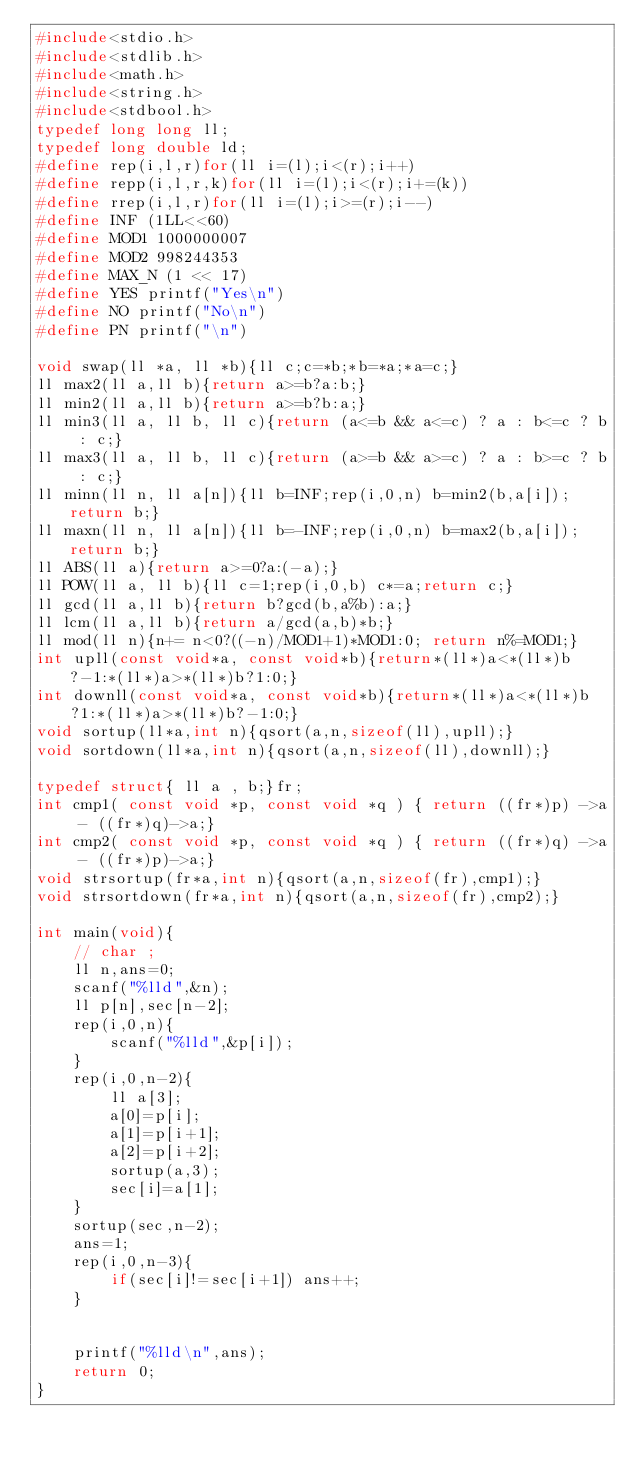Convert code to text. <code><loc_0><loc_0><loc_500><loc_500><_C_>#include<stdio.h>
#include<stdlib.h>
#include<math.h>
#include<string.h>
#include<stdbool.h>
typedef long long ll;
typedef long double ld;
#define rep(i,l,r)for(ll i=(l);i<(r);i++)
#define repp(i,l,r,k)for(ll i=(l);i<(r);i+=(k))
#define rrep(i,l,r)for(ll i=(l);i>=(r);i--)
#define INF (1LL<<60)
#define MOD1 1000000007
#define MOD2 998244353
#define MAX_N (1 << 17)
#define YES printf("Yes\n")
#define NO printf("No\n")
#define PN printf("\n")

void swap(ll *a, ll *b){ll c;c=*b;*b=*a;*a=c;}
ll max2(ll a,ll b){return a>=b?a:b;}
ll min2(ll a,ll b){return a>=b?b:a;}
ll min3(ll a, ll b, ll c){return (a<=b && a<=c) ? a : b<=c ? b : c;}
ll max3(ll a, ll b, ll c){return (a>=b && a>=c) ? a : b>=c ? b : c;}
ll minn(ll n, ll a[n]){ll b=INF;rep(i,0,n) b=min2(b,a[i]);return b;}
ll maxn(ll n, ll a[n]){ll b=-INF;rep(i,0,n) b=max2(b,a[i]);return b;}
ll ABS(ll a){return a>=0?a:(-a);}
ll POW(ll a, ll b){ll c=1;rep(i,0,b) c*=a;return c;}
ll gcd(ll a,ll b){return b?gcd(b,a%b):a;}
ll lcm(ll a,ll b){return a/gcd(a,b)*b;}
ll mod(ll n){n+= n<0?((-n)/MOD1+1)*MOD1:0; return n%=MOD1;}
int upll(const void*a, const void*b){return*(ll*)a<*(ll*)b?-1:*(ll*)a>*(ll*)b?1:0;}
int downll(const void*a, const void*b){return*(ll*)a<*(ll*)b?1:*(ll*)a>*(ll*)b?-1:0;}
void sortup(ll*a,int n){qsort(a,n,sizeof(ll),upll);}
void sortdown(ll*a,int n){qsort(a,n,sizeof(ll),downll);}

typedef struct{ ll a , b;}fr;
int cmp1( const void *p, const void *q ) { return ((fr*)p) ->a - ((fr*)q)->a;}
int cmp2( const void *p, const void *q ) { return ((fr*)q) ->a - ((fr*)p)->a;}
void strsortup(fr*a,int n){qsort(a,n,sizeof(fr),cmp1);}
void strsortdown(fr*a,int n){qsort(a,n,sizeof(fr),cmp2);}

int main(void){
    // char ;
    ll n,ans=0;
    scanf("%lld",&n);
    ll p[n],sec[n-2];
    rep(i,0,n){
        scanf("%lld",&p[i]);
    }
    rep(i,0,n-2){
        ll a[3];
        a[0]=p[i];
        a[1]=p[i+1];
        a[2]=p[i+2];
        sortup(a,3);
        sec[i]=a[1];
    }
    sortup(sec,n-2);
    ans=1;
    rep(i,0,n-3){
        if(sec[i]!=sec[i+1]) ans++;
    }

    
    printf("%lld\n",ans);
    return 0;
}
</code> 